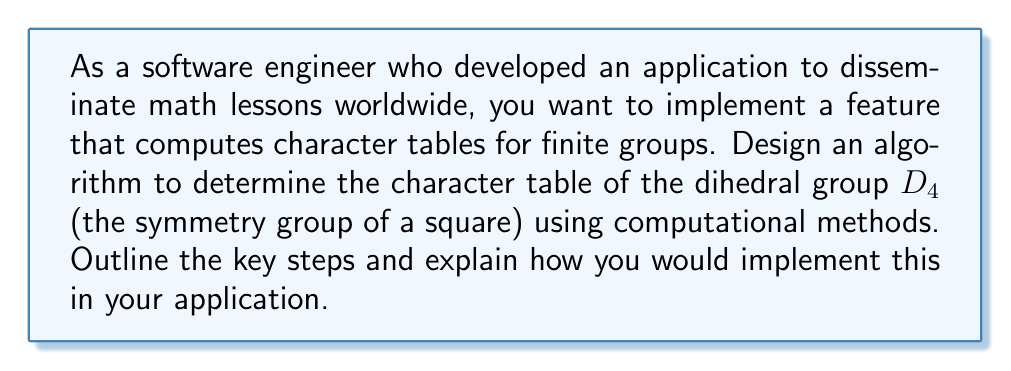Could you help me with this problem? To determine the character table of $D_4$ computationally, we can follow these steps:

1. Identify the elements of $D_4$:
   $D_4 = \{e, r, r^2, r^3, s, sr, sr^2, sr^3\}$
   Where $e$ is the identity, $r$ is a 90° rotation, and $s$ is a reflection.

2. Find the conjugacy classes:
   $\{e\}$, $\{r^2\}$, $\{r, r^3\}$, $\{s, sr^2\}$, $\{sr, sr^3\}$

3. Determine the number of irreducible representations:
   Number of irreducible representations = Number of conjugacy classes = 5

4. Find the dimensions of irreducible representations:
   $\sum_{i=1}^5 d_i^2 = |D_4| = 8$
   We can deduce: $d_1 = d_2 = d_3 = d_4 = 1$, $d_5 = 2$

5. Compute the characters for the trivial representation:
   $\chi_1(g) = 1$ for all $g \in D_4$

6. Compute the characters for other 1-dimensional representations:
   $\chi_2(e) = \chi_2(r^2) = \chi_2(s) = \chi_2(sr^2) = 1$, $\chi_2(r) = \chi_2(r^3) = \chi_2(sr) = \chi_2(sr^3) = -1$
   $\chi_3(e) = \chi_3(r^2) = \chi_3(sr) = \chi_3(sr^3) = 1$, $\chi_3(r) = \chi_3(r^3) = \chi_3(s) = \chi_3(sr^2) = -1$
   $\chi_4(e) = \chi_4(r^2) = 1$, $\chi_4(r) = \chi_4(r^3) = -1$, $\chi_4(s) = \chi_4(sr) = \chi_4(sr^2) = \chi_4(sr^3) = 0$

7. Compute the characters for the 2-dimensional representation:
   $\chi_5(e) = 2$, $\chi_5(r^2) = -2$, $\chi_5(r) = \chi_5(r^3) = 0$, $\chi_5(s) = \chi_5(sr) = \chi_5(sr^2) = \chi_5(sr^3) = 0$

8. Verify orthogonality relations and completeness.

Implementation in the application:
- Create data structures to represent groups and their elements.
- Implement algorithms for finding conjugacy classes and computing characters.
- Use linear algebra libraries for matrix operations and eigenvalue calculations.
- Implement checks for orthogonality and completeness of the character table.
- Design a user interface to input group information and display the resulting character table.
Answer: Character table of $D_4$:

$$
\begin{array}{c|ccccc}
D_4 & \{e\} & \{r^2\} & \{r,r^3\} & \{s,sr^2\} & \{sr,sr^3\} \\
\hline
\chi_1 & 1 & 1 & 1 & 1 & 1 \\
\chi_2 & 1 & 1 & -1 & 1 & -1 \\
\chi_3 & 1 & 1 & -1 & -1 & 1 \\
\chi_4 & 1 & 1 & 1 & -1 & -1 \\
\chi_5 & 2 & -2 & 0 & 0 & 0
\end{array}
$$ 